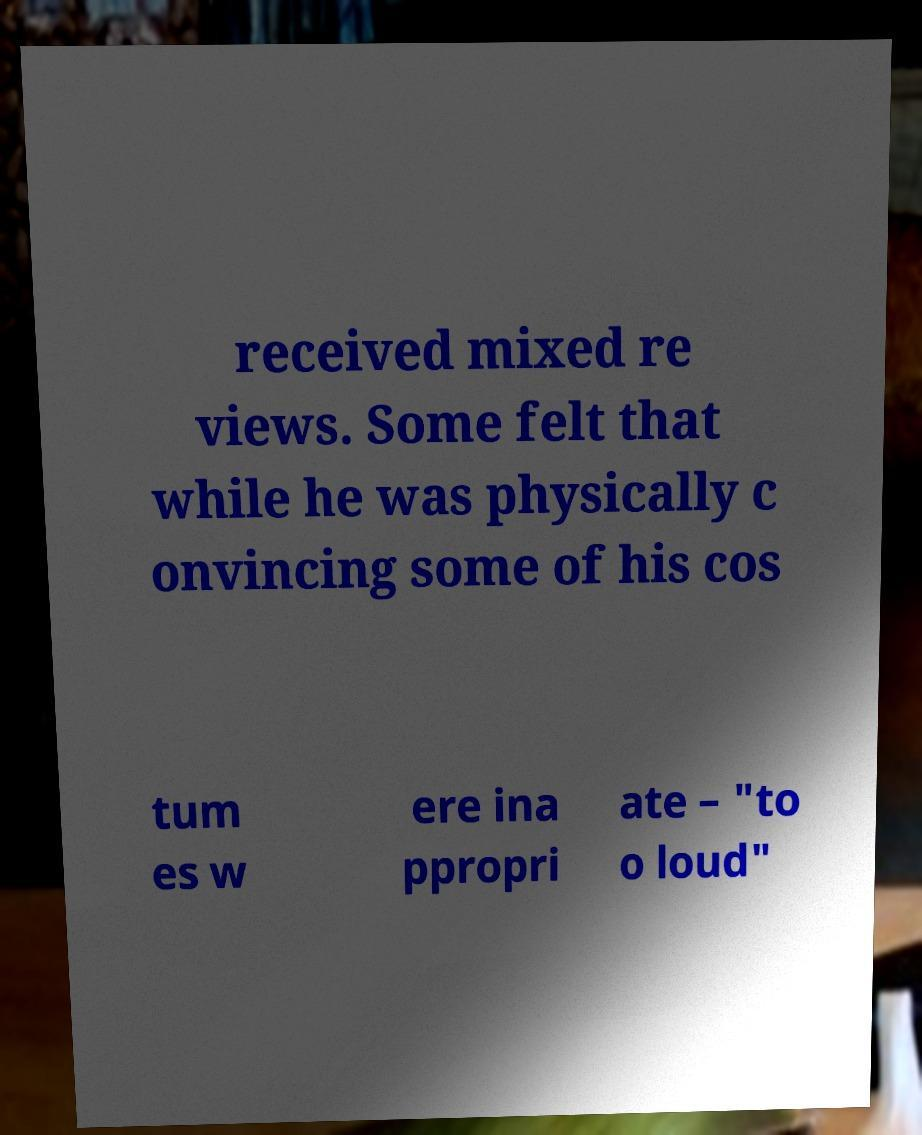Could you extract and type out the text from this image? received mixed re views. Some felt that while he was physically c onvincing some of his cos tum es w ere ina ppropri ate – "to o loud" 